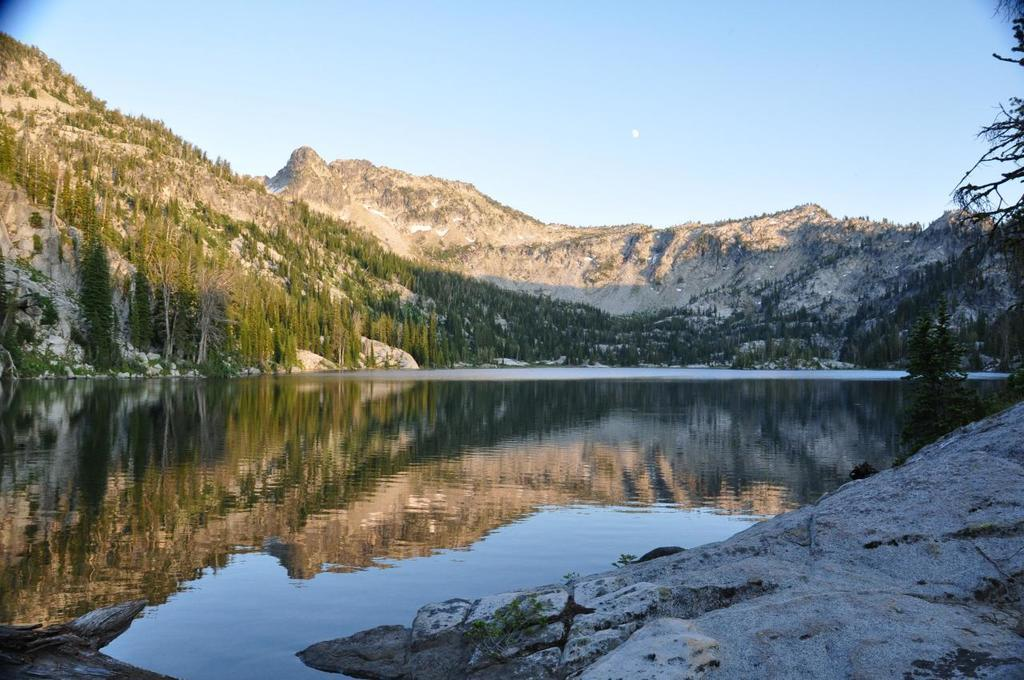What type of natural landform can be seen in the image? There are mountains in the image. What other natural elements are present in the image? There are trees and rocks in the image. How are the rocks interacting with the water in the image? The rocks have a reflection in the water of a lake. What is visible at the top of the image? The sky is visible at the top of the image. Can you see a wheel in harmony with the goldfish in the image? There is no wheel or goldfish present in the image. 